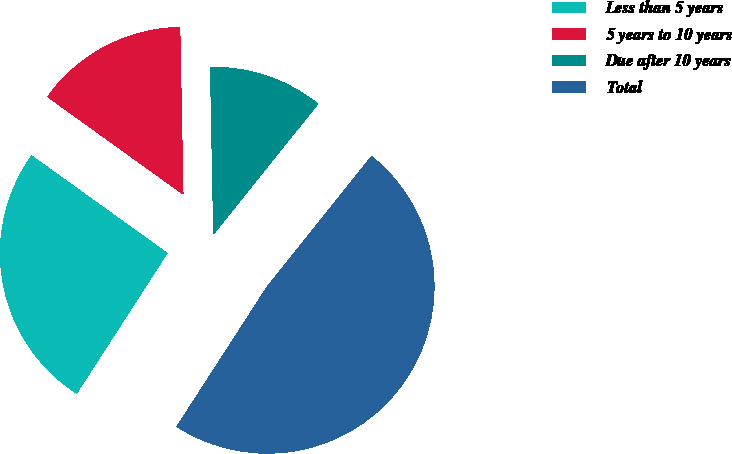Convert chart to OTSL. <chart><loc_0><loc_0><loc_500><loc_500><pie_chart><fcel>Less than 5 years<fcel>5 years to 10 years<fcel>Due after 10 years<fcel>Total<nl><fcel>25.79%<fcel>14.78%<fcel>11.05%<fcel>48.38%<nl></chart> 